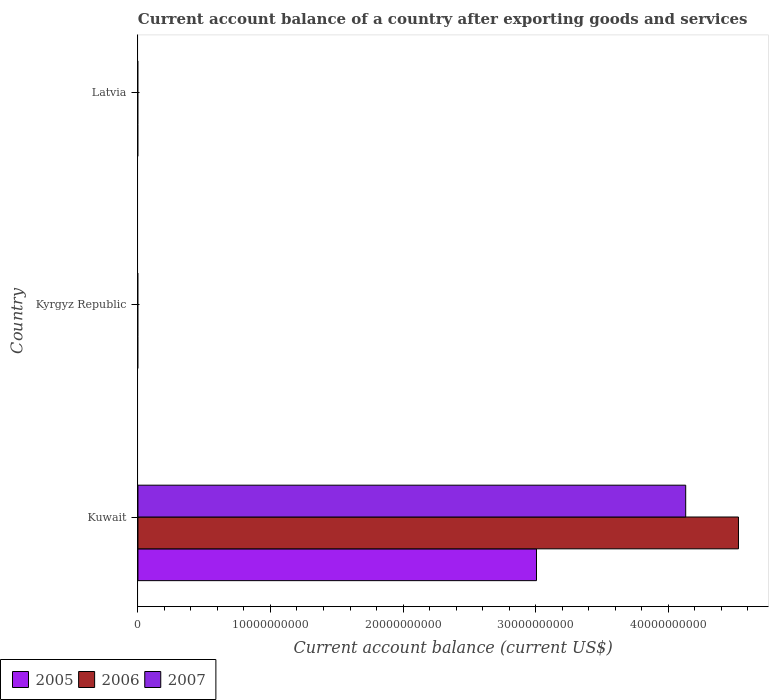How many different coloured bars are there?
Make the answer very short. 3. Are the number of bars per tick equal to the number of legend labels?
Your response must be concise. No. What is the label of the 3rd group of bars from the top?
Make the answer very short. Kuwait. Across all countries, what is the maximum account balance in 2006?
Make the answer very short. 4.53e+1. Across all countries, what is the minimum account balance in 2006?
Offer a terse response. 0. In which country was the account balance in 2006 maximum?
Keep it short and to the point. Kuwait. What is the total account balance in 2006 in the graph?
Provide a short and direct response. 4.53e+1. What is the difference between the account balance in 2007 in Kuwait and the account balance in 2005 in Kyrgyz Republic?
Provide a short and direct response. 4.13e+1. What is the average account balance in 2006 per country?
Keep it short and to the point. 1.51e+1. What is the difference between the account balance in 2006 and account balance in 2005 in Kuwait?
Offer a terse response. 1.52e+1. In how many countries, is the account balance in 2007 greater than 16000000000 US$?
Make the answer very short. 1. What is the difference between the highest and the lowest account balance in 2006?
Provide a succinct answer. 4.53e+1. Is it the case that in every country, the sum of the account balance in 2006 and account balance in 2007 is greater than the account balance in 2005?
Your answer should be compact. No. Are all the bars in the graph horizontal?
Your response must be concise. Yes. How many countries are there in the graph?
Provide a succinct answer. 3. What is the difference between two consecutive major ticks on the X-axis?
Your answer should be compact. 1.00e+1. Are the values on the major ticks of X-axis written in scientific E-notation?
Your answer should be very brief. No. Where does the legend appear in the graph?
Offer a very short reply. Bottom left. How many legend labels are there?
Make the answer very short. 3. What is the title of the graph?
Provide a succinct answer. Current account balance of a country after exporting goods and services. Does "1962" appear as one of the legend labels in the graph?
Provide a succinct answer. No. What is the label or title of the X-axis?
Your answer should be very brief. Current account balance (current US$). What is the Current account balance (current US$) in 2005 in Kuwait?
Keep it short and to the point. 3.01e+1. What is the Current account balance (current US$) in 2006 in Kuwait?
Your answer should be very brief. 4.53e+1. What is the Current account balance (current US$) of 2007 in Kuwait?
Keep it short and to the point. 4.13e+1. What is the Current account balance (current US$) in 2005 in Kyrgyz Republic?
Provide a short and direct response. 0. What is the Current account balance (current US$) of 2006 in Kyrgyz Republic?
Ensure brevity in your answer.  0. What is the Current account balance (current US$) in 2007 in Latvia?
Your response must be concise. 0. Across all countries, what is the maximum Current account balance (current US$) of 2005?
Provide a short and direct response. 3.01e+1. Across all countries, what is the maximum Current account balance (current US$) of 2006?
Ensure brevity in your answer.  4.53e+1. Across all countries, what is the maximum Current account balance (current US$) in 2007?
Provide a short and direct response. 4.13e+1. Across all countries, what is the minimum Current account balance (current US$) of 2007?
Ensure brevity in your answer.  0. What is the total Current account balance (current US$) of 2005 in the graph?
Your answer should be compact. 3.01e+1. What is the total Current account balance (current US$) in 2006 in the graph?
Offer a very short reply. 4.53e+1. What is the total Current account balance (current US$) in 2007 in the graph?
Provide a succinct answer. 4.13e+1. What is the average Current account balance (current US$) of 2005 per country?
Provide a short and direct response. 1.00e+1. What is the average Current account balance (current US$) of 2006 per country?
Make the answer very short. 1.51e+1. What is the average Current account balance (current US$) of 2007 per country?
Provide a short and direct response. 1.38e+1. What is the difference between the Current account balance (current US$) in 2005 and Current account balance (current US$) in 2006 in Kuwait?
Offer a very short reply. -1.52e+1. What is the difference between the Current account balance (current US$) in 2005 and Current account balance (current US$) in 2007 in Kuwait?
Ensure brevity in your answer.  -1.13e+1. What is the difference between the Current account balance (current US$) of 2006 and Current account balance (current US$) of 2007 in Kuwait?
Keep it short and to the point. 3.98e+09. What is the difference between the highest and the lowest Current account balance (current US$) in 2005?
Offer a very short reply. 3.01e+1. What is the difference between the highest and the lowest Current account balance (current US$) of 2006?
Your answer should be compact. 4.53e+1. What is the difference between the highest and the lowest Current account balance (current US$) of 2007?
Offer a very short reply. 4.13e+1. 